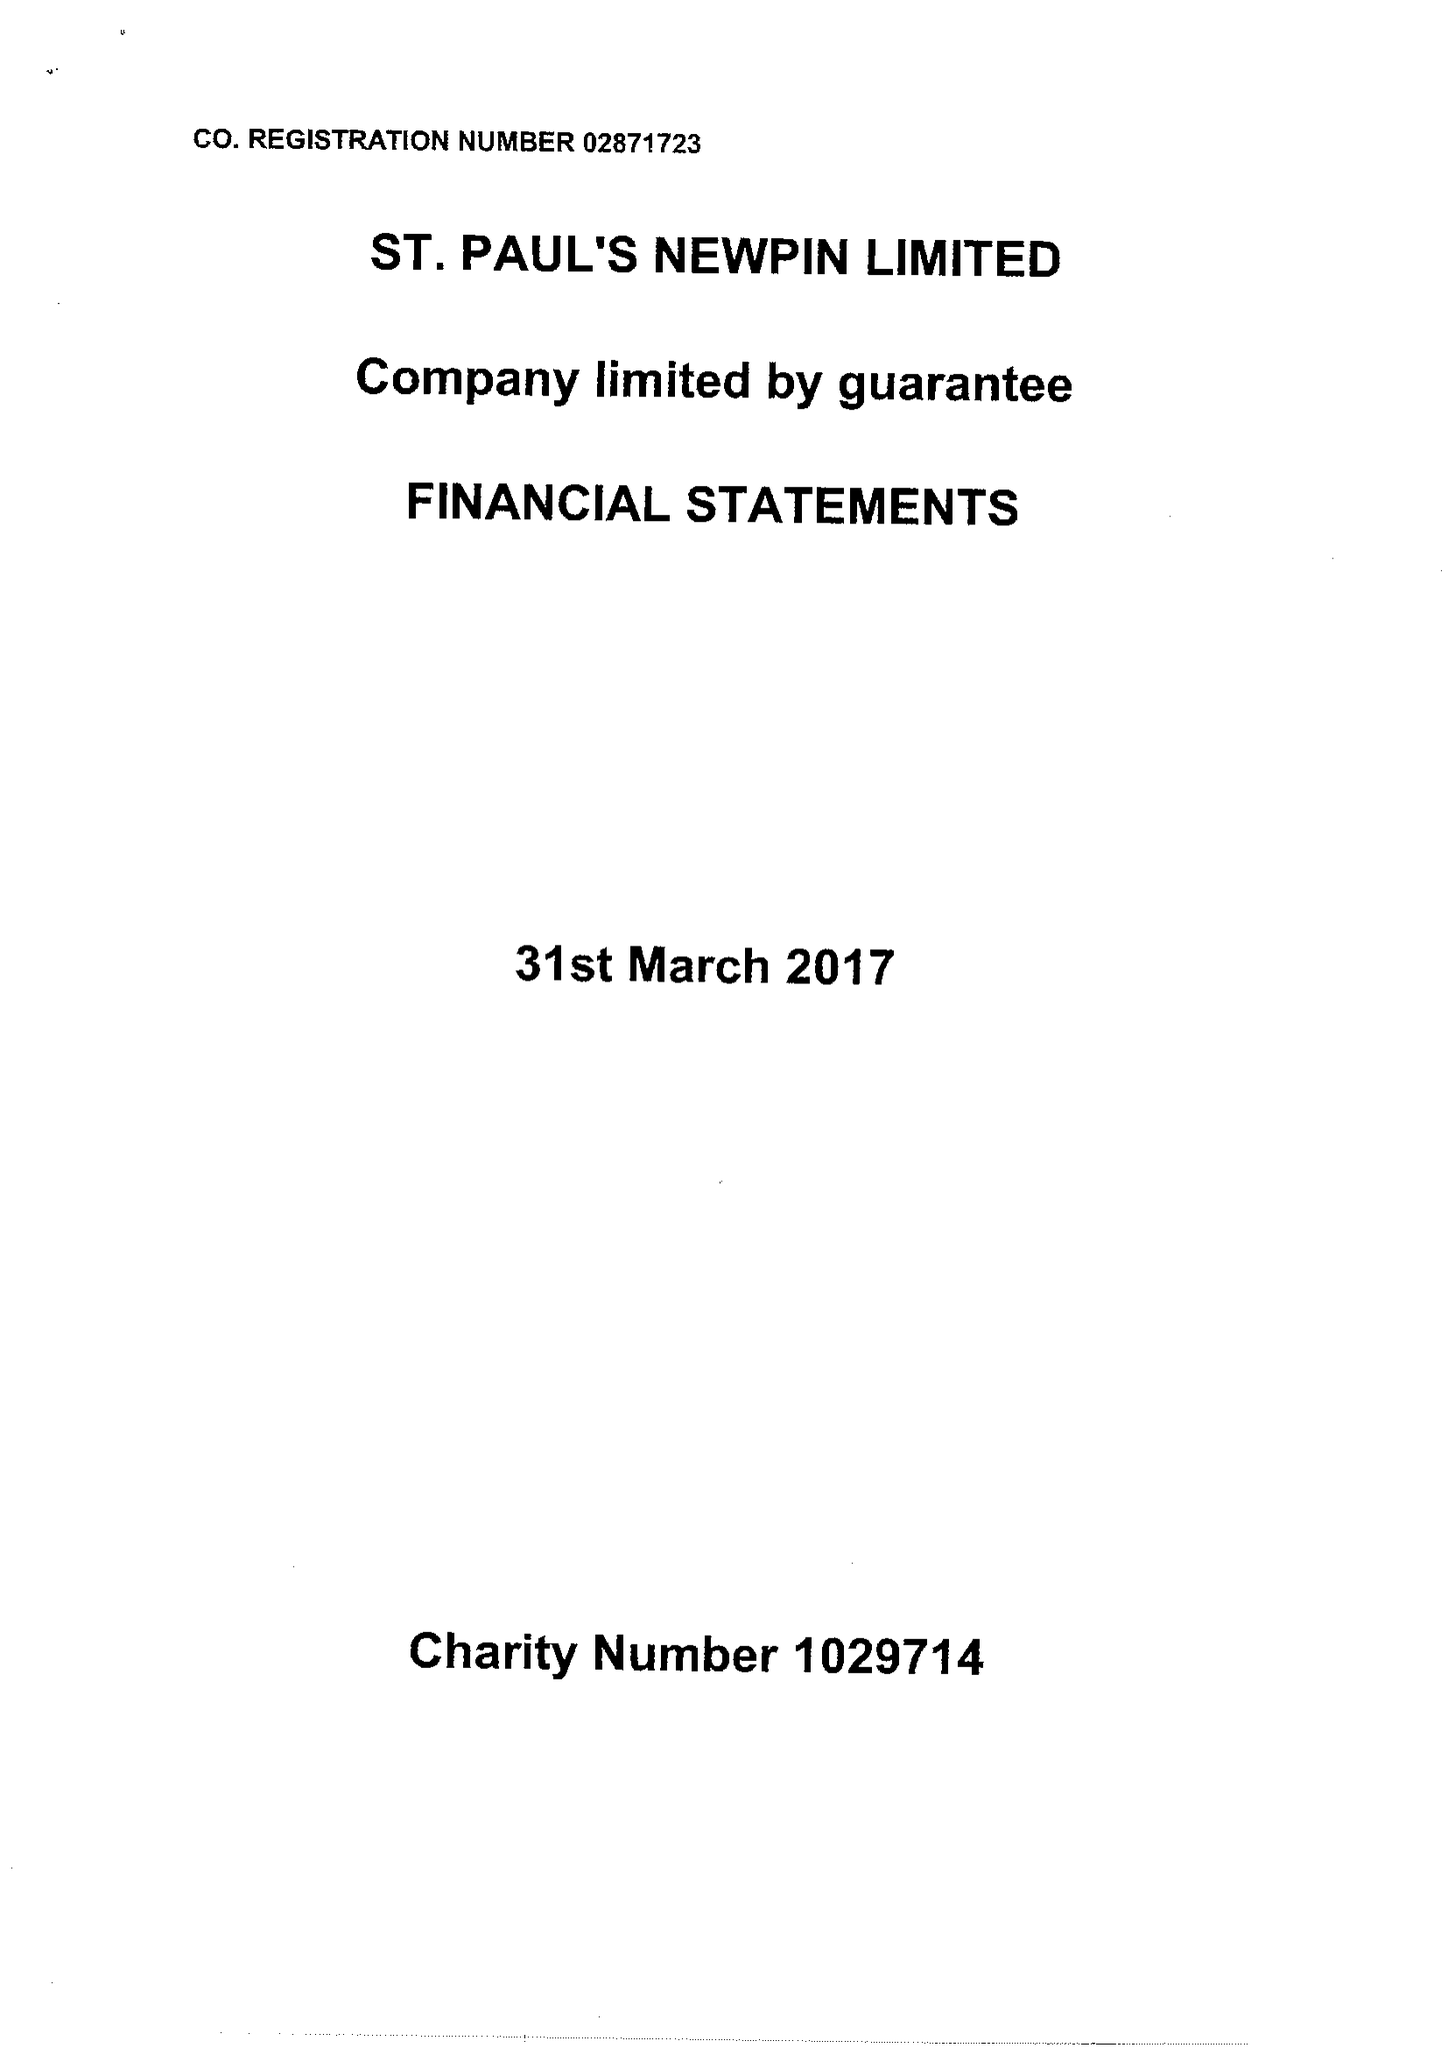What is the value for the address__post_town?
Answer the question using a single word or phrase. LONDON 